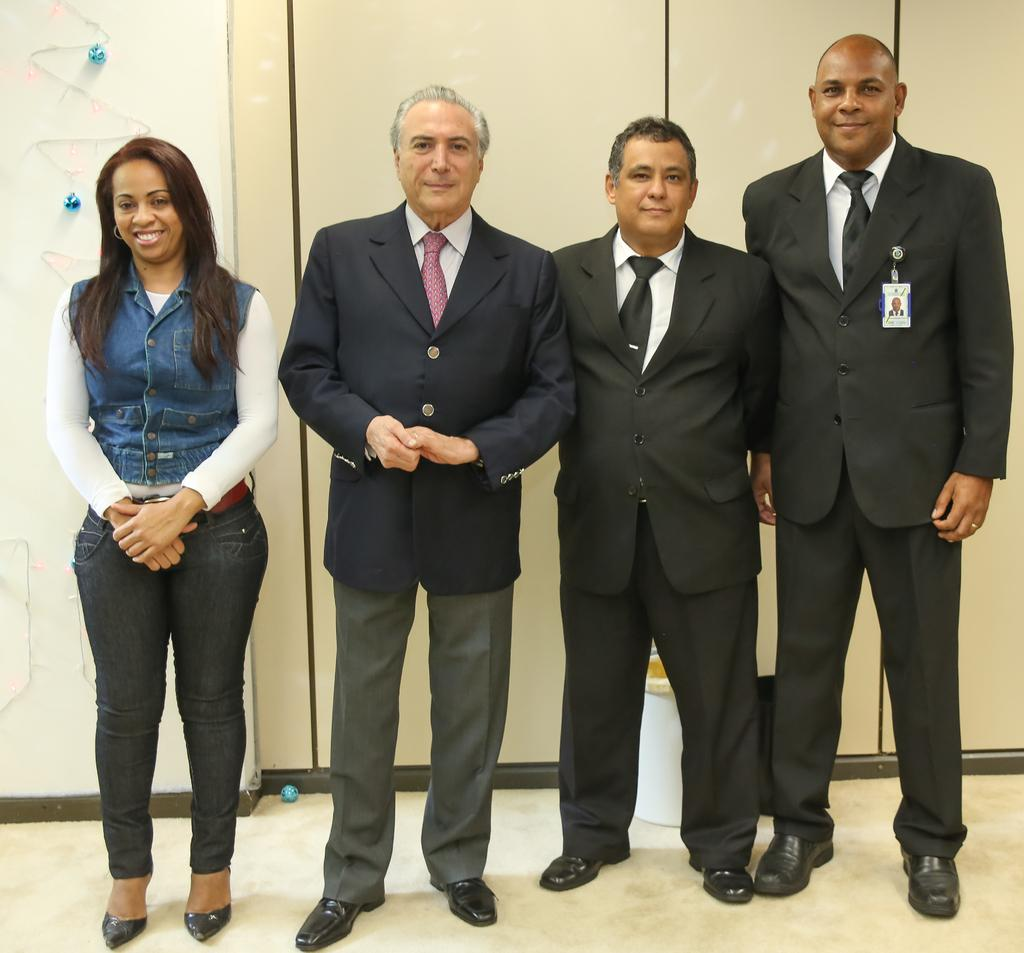What are the people in the image doing? The people are standing in the center of the image. What can be seen behind the people in the image? There is a wall and objects in the background of the image. What is the surface that the people are standing on? There is a floor at the bottom of the image. How does the range of colors in the image affect the hearing of the people in the image? The range of colors in the image does not affect the hearing of the people, as colors and sounds are separate sensory experiences. 